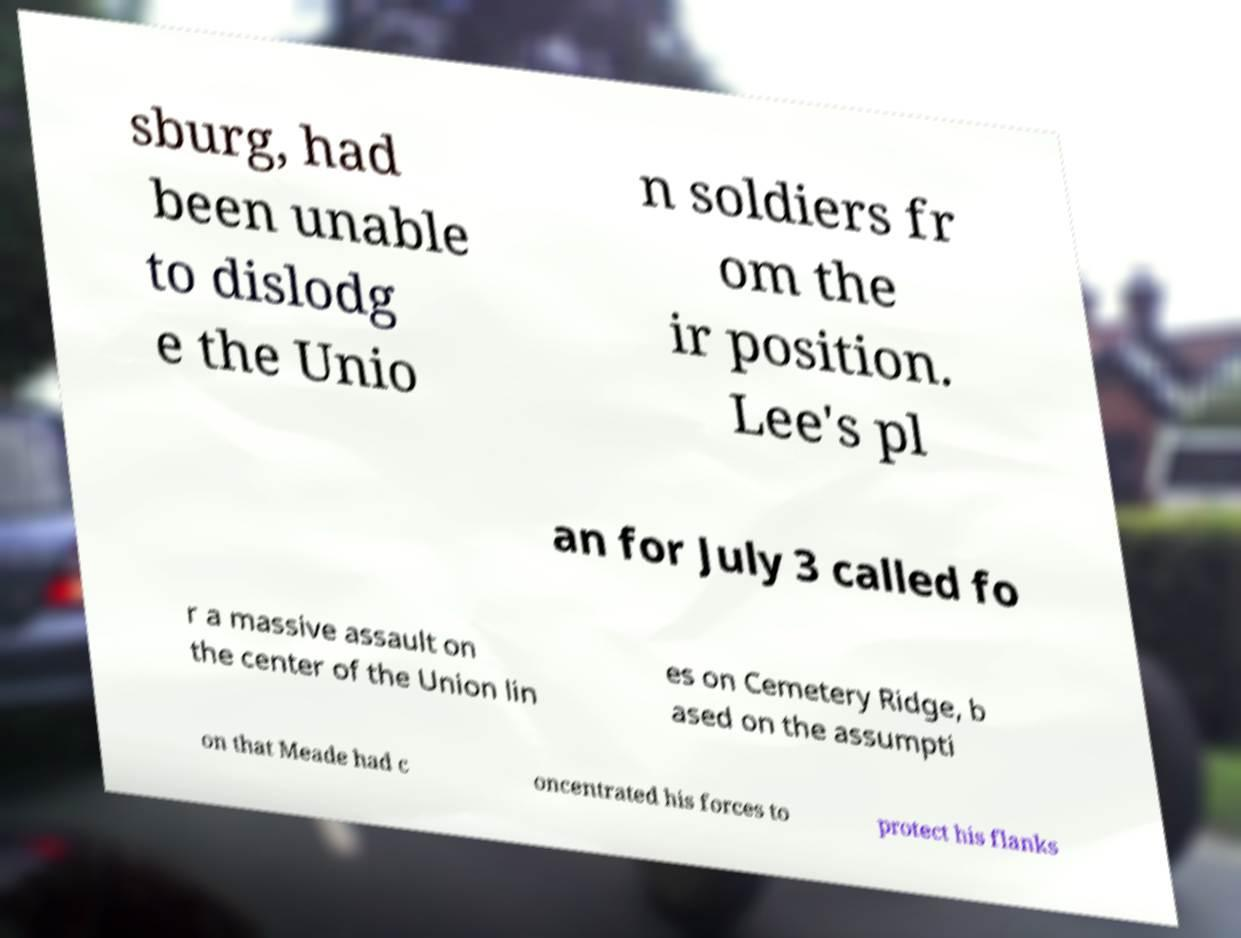Can you accurately transcribe the text from the provided image for me? sburg, had been unable to dislodg e the Unio n soldiers fr om the ir position. Lee's pl an for July 3 called fo r a massive assault on the center of the Union lin es on Cemetery Ridge, b ased on the assumpti on that Meade had c oncentrated his forces to protect his flanks 